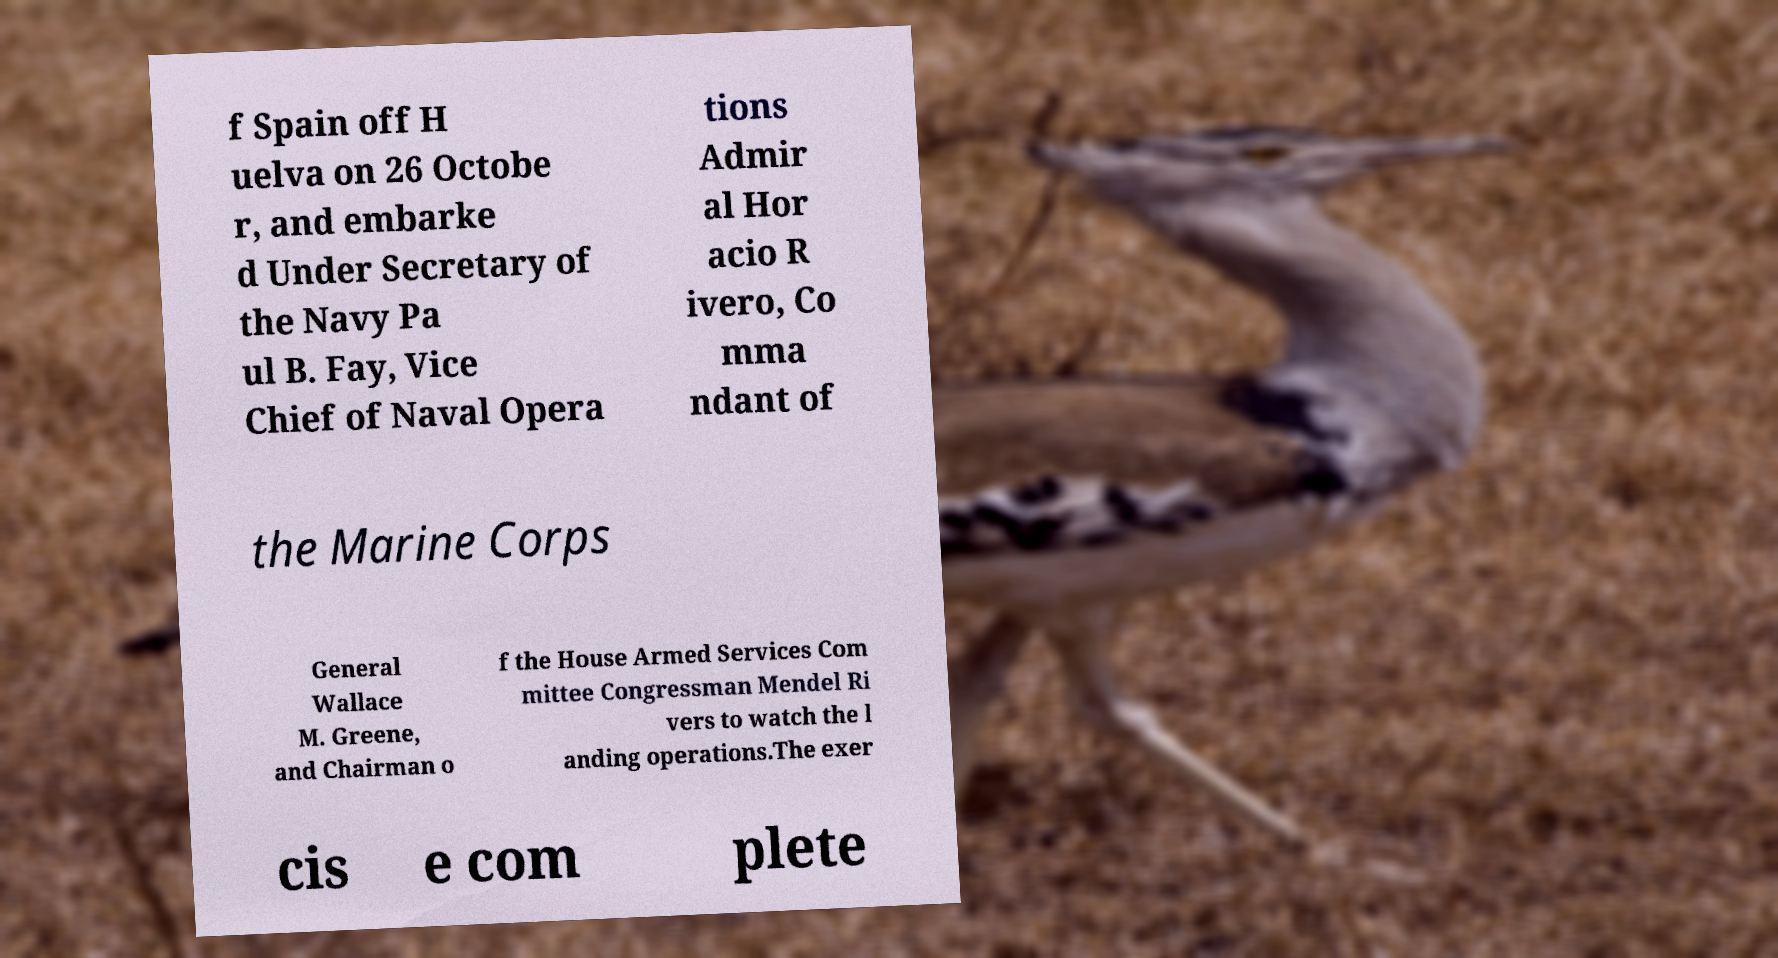What messages or text are displayed in this image? I need them in a readable, typed format. f Spain off H uelva on 26 Octobe r, and embarke d Under Secretary of the Navy Pa ul B. Fay, Vice Chief of Naval Opera tions Admir al Hor acio R ivero, Co mma ndant of the Marine Corps General Wallace M. Greene, and Chairman o f the House Armed Services Com mittee Congressman Mendel Ri vers to watch the l anding operations.The exer cis e com plete 